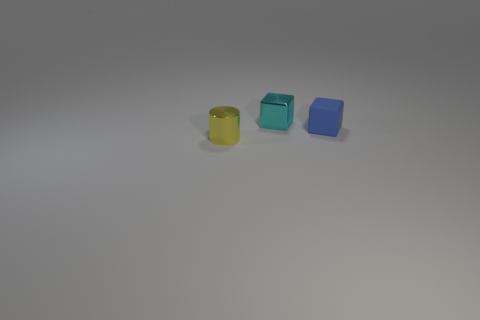Add 1 cyan things. How many objects exist? 4 Subtract all cylinders. How many objects are left? 2 Add 2 small yellow metallic cylinders. How many small yellow metallic cylinders exist? 3 Subtract 0 blue cylinders. How many objects are left? 3 Subtract all small objects. Subtract all purple matte objects. How many objects are left? 0 Add 3 yellow cylinders. How many yellow cylinders are left? 4 